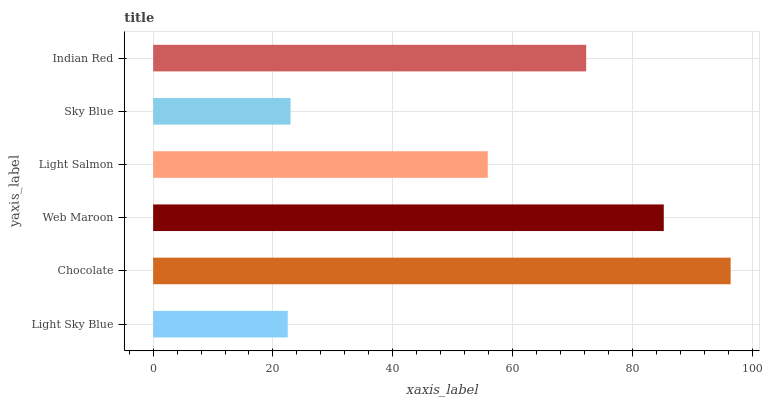Is Light Sky Blue the minimum?
Answer yes or no. Yes. Is Chocolate the maximum?
Answer yes or no. Yes. Is Web Maroon the minimum?
Answer yes or no. No. Is Web Maroon the maximum?
Answer yes or no. No. Is Chocolate greater than Web Maroon?
Answer yes or no. Yes. Is Web Maroon less than Chocolate?
Answer yes or no. Yes. Is Web Maroon greater than Chocolate?
Answer yes or no. No. Is Chocolate less than Web Maroon?
Answer yes or no. No. Is Indian Red the high median?
Answer yes or no. Yes. Is Light Salmon the low median?
Answer yes or no. Yes. Is Chocolate the high median?
Answer yes or no. No. Is Light Sky Blue the low median?
Answer yes or no. No. 